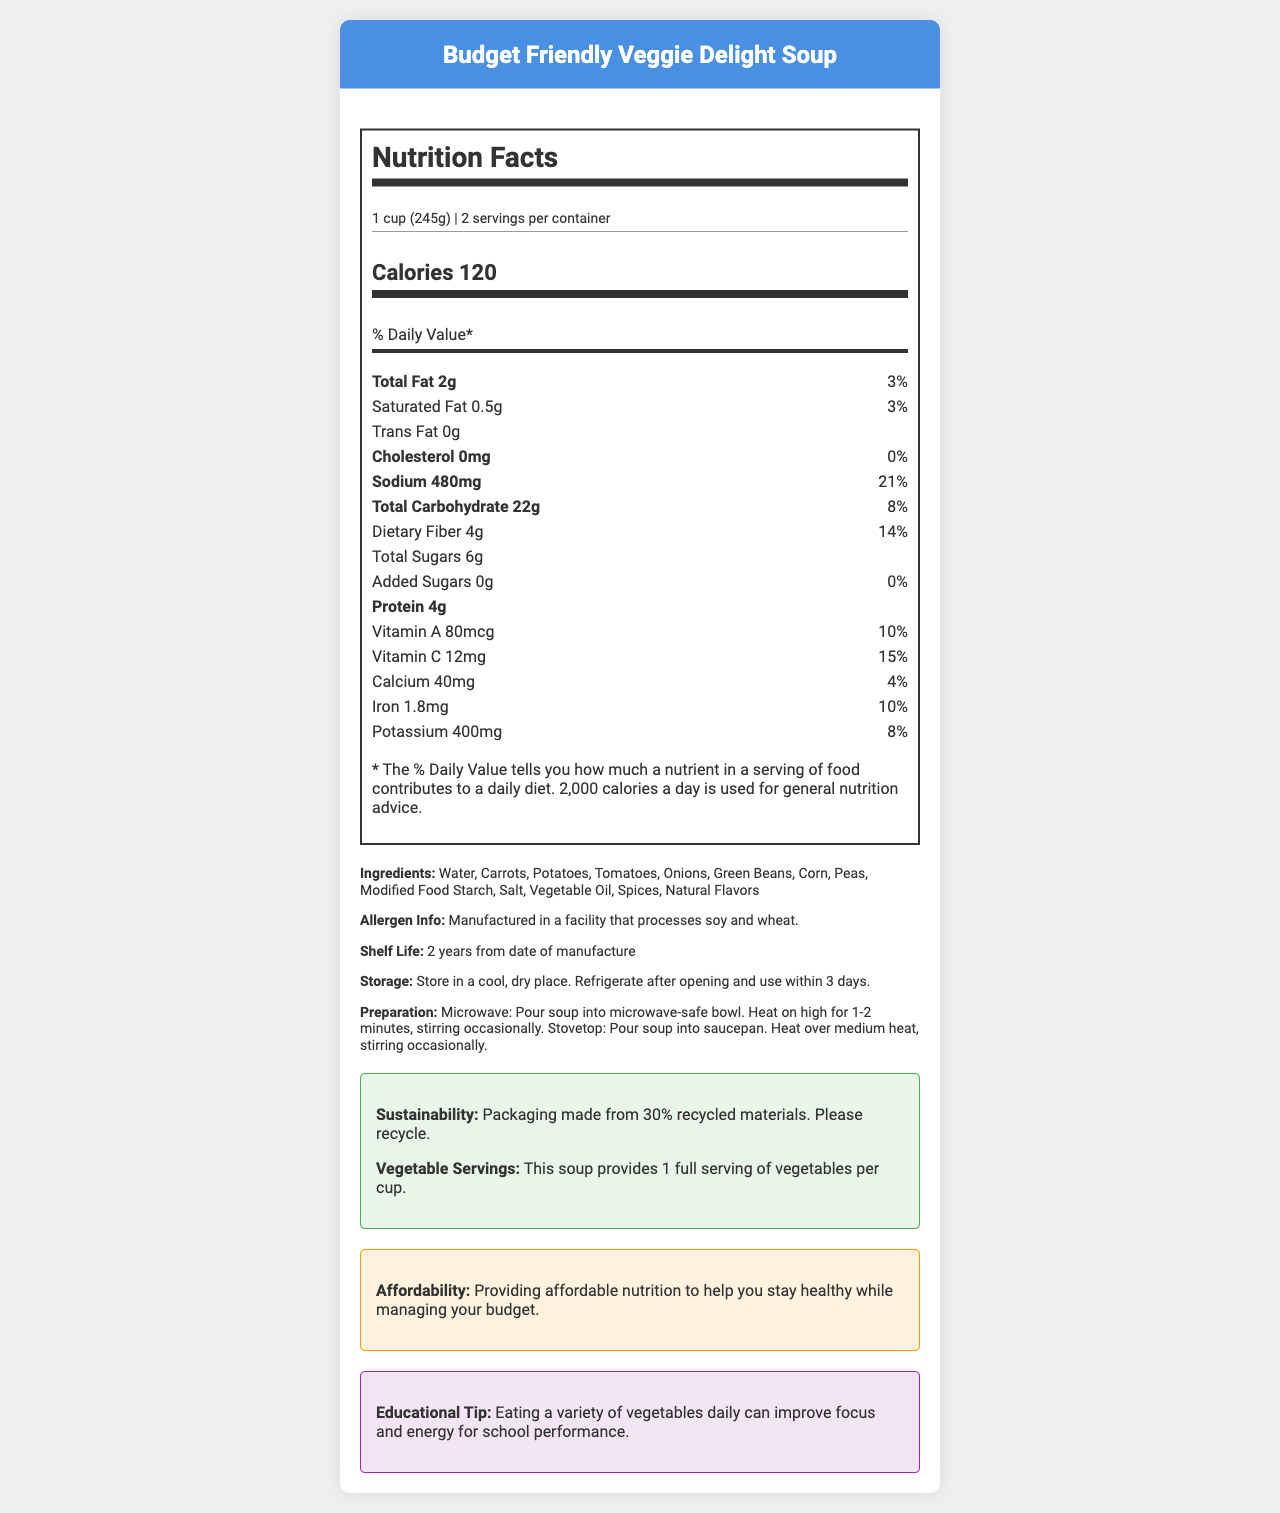what is the product name? The product name is prominently displayed at the top of the document.
Answer: Budget Friendly Veggie Delight Soup what is the serving size? The serving size is mentioned in the nutrition facts section under "serving size".
Answer: 1 cup (245g) how much protein is in one serving? The protein content is listed under the nutrients section in the nutrition facts.
Answer: 4g how many servings are in one container? The number of servings per container is mentioned alongside the serving size in the nutrition facts section.
Answer: 2 what percentage of the daily value of sodium is in one serving? The sodium daily value percentage is listed in the nutrition facts under sodium.
Answer: 21% which ingredient is listed first? Ingredients are listed by quantity, with the most abundant first. Water is the first on the ingredient list.
Answer: Water What should you do after opening the soup? This information is listed under the storage instructions in the document.
Answer: Refrigerate after opening and use within 3 days What are the preparation methods mentioned for this soup? A. Microwave and Stovetop B. Oven and Stovetop C. Microwave and Oven D. Stovetop and Grill The preparation instructions mention microwave and stovetop as the methods for heating the soup.
Answer: A. Microwave and Stovetop How long is the shelf life of this soup? A. 1 year B. 2 years C. 3 years D. 5 years The shelf life is stated as 2 years from the date of manufacture in the document.
Answer: B. 2 years Which nutrient provides 15% of the daily value? A. Vitamin A B. Iron C. Vitamin C D. Calcium According to the nutrition facts, Vitamin C provides 15% of the daily value.
Answer: C. Vitamin C Is this soup low in trans fat? The document states that the trans fat content is 0g, which means it is low in trans fat.
Answer: Yes Summarize the main idea of the document. The document provides detailed information about the soup, including nutritional content, ingredients, preparation methods, storage instructions, sustainability information, and an educational tip.
Answer: The document is about a Budget Friendly Veggie Delight Soup, detailing its nutrition facts, ingredients, preparation and storage instructions, and additional health and sustainability information. Can this document tell us the price of the soup? The document does not provide any details related to the price or cost of the soup.
Answer: Not enough information 